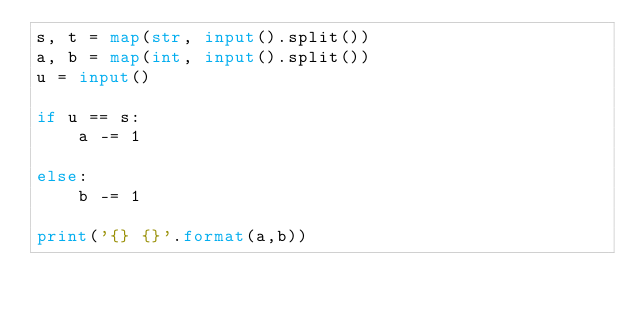Convert code to text. <code><loc_0><loc_0><loc_500><loc_500><_Python_>s, t = map(str, input().split())
a, b = map(int, input().split())
u = input()

if u == s:
    a -= 1

else:
    b -= 1

print('{} {}'.format(a,b))</code> 